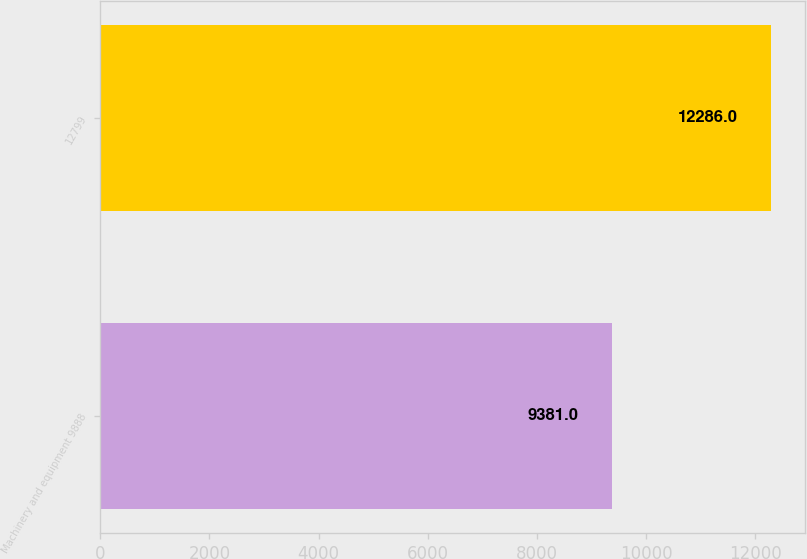Convert chart to OTSL. <chart><loc_0><loc_0><loc_500><loc_500><bar_chart><fcel>Machinery and equipment 9888<fcel>12799<nl><fcel>9381<fcel>12286<nl></chart> 